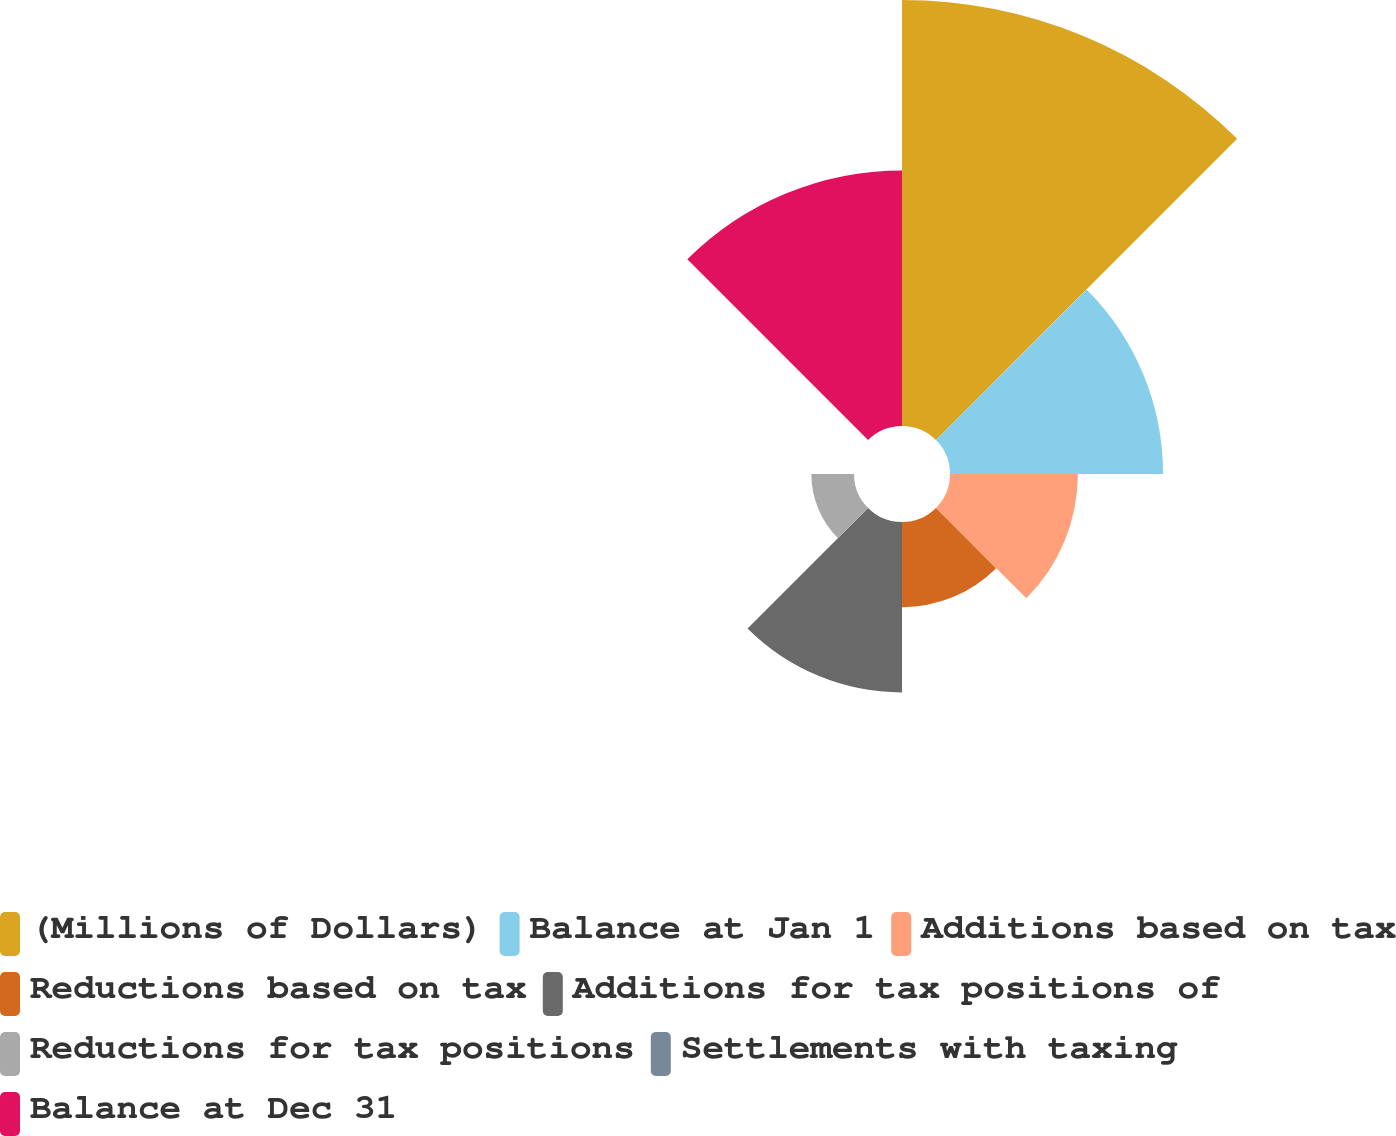Convert chart to OTSL. <chart><loc_0><loc_0><loc_500><loc_500><pie_chart><fcel>(Millions of Dollars)<fcel>Balance at Jan 1<fcel>Additions based on tax<fcel>Reductions based on tax<fcel>Additions for tax positions of<fcel>Reductions for tax positions<fcel>Settlements with taxing<fcel>Balance at Dec 31<nl><fcel>32.25%<fcel>16.13%<fcel>9.68%<fcel>6.45%<fcel>12.9%<fcel>3.23%<fcel>0.0%<fcel>19.35%<nl></chart> 